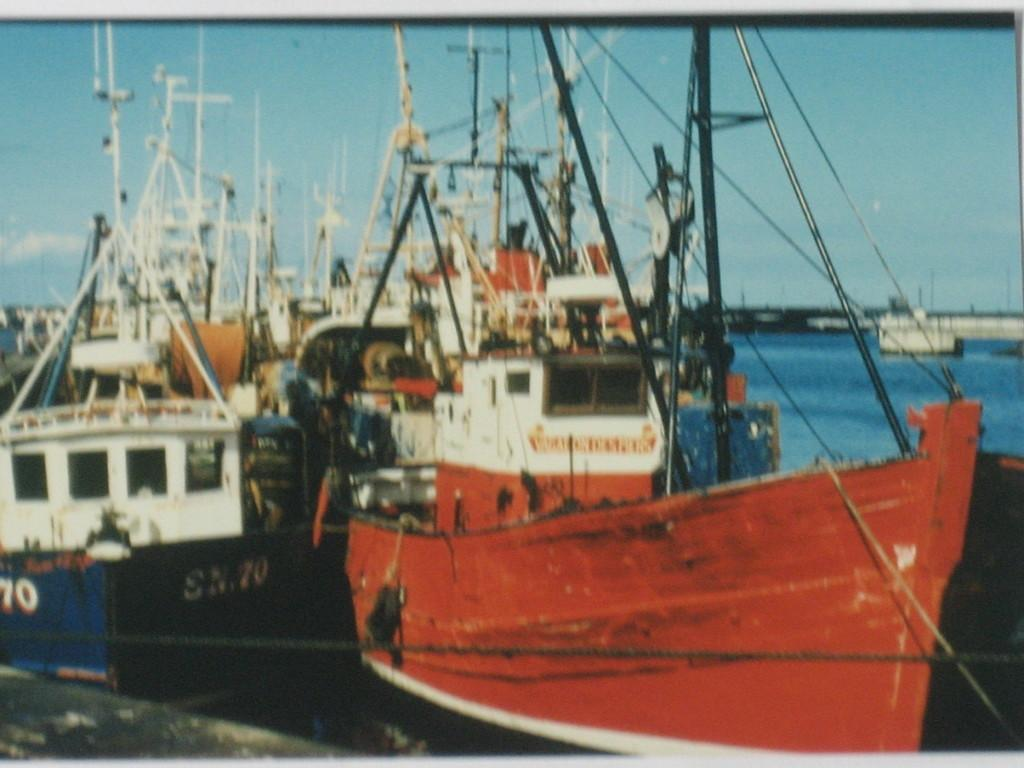<image>
Give a short and clear explanation of the subsequent image. A ship labeled SN.70 sits next to another. 